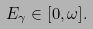<formula> <loc_0><loc_0><loc_500><loc_500>E _ { \gamma } \in [ 0 , \omega ] .</formula> 